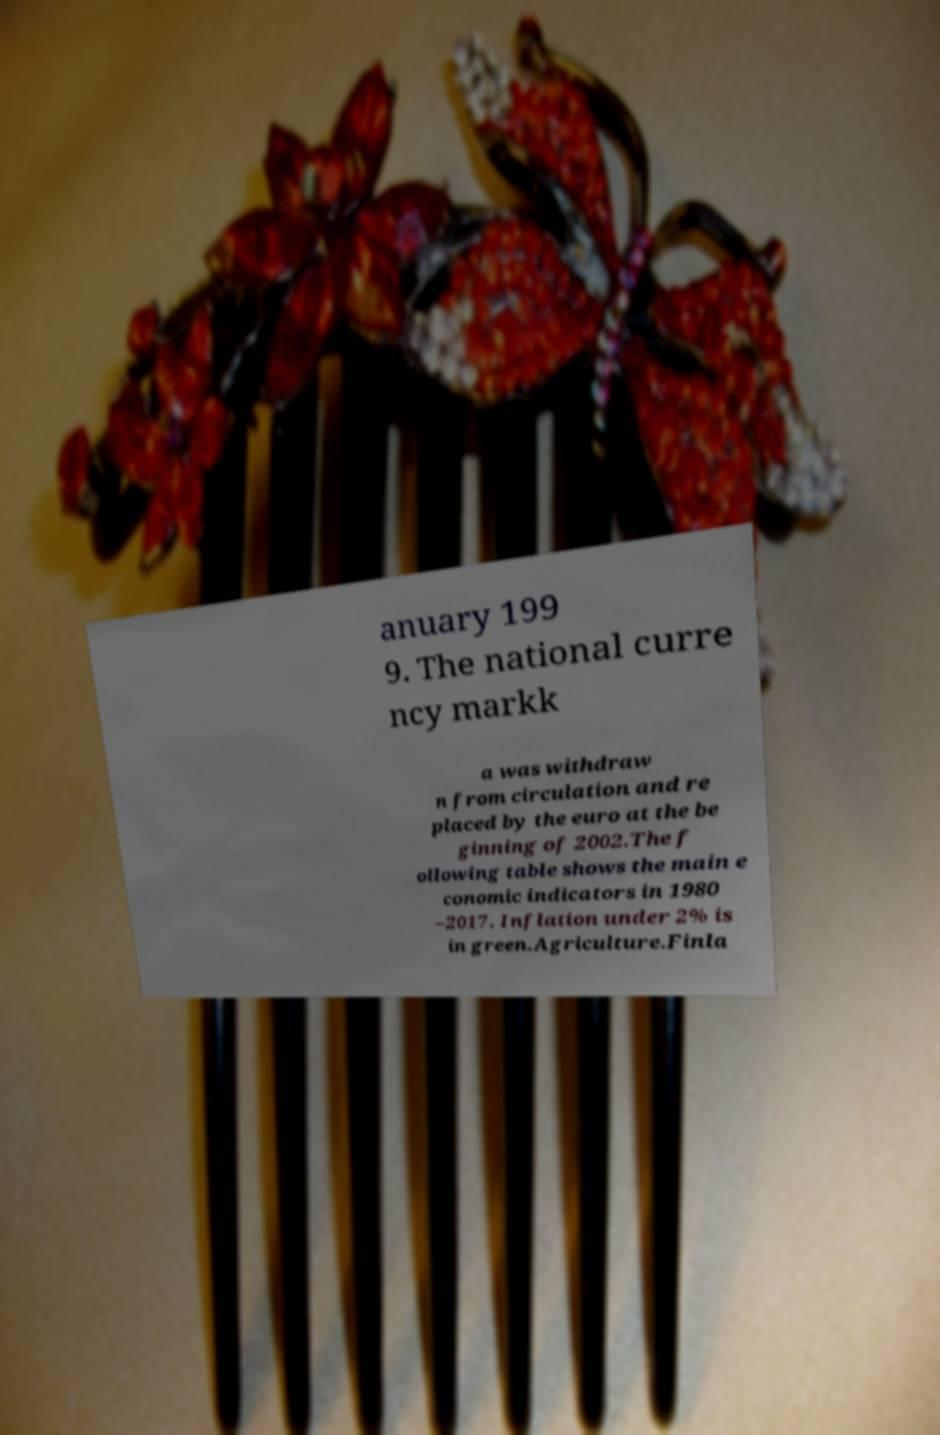There's text embedded in this image that I need extracted. Can you transcribe it verbatim? anuary 199 9. The national curre ncy markk a was withdraw n from circulation and re placed by the euro at the be ginning of 2002.The f ollowing table shows the main e conomic indicators in 1980 –2017. Inflation under 2% is in green.Agriculture.Finla 